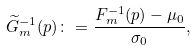Convert formula to latex. <formula><loc_0><loc_0><loc_500><loc_500>\widetilde { G } _ { m } ^ { - 1 } ( p ) \colon = \frac { F _ { m } ^ { - 1 } ( p ) - \mu _ { 0 } } { \sigma _ { 0 } } ,</formula> 